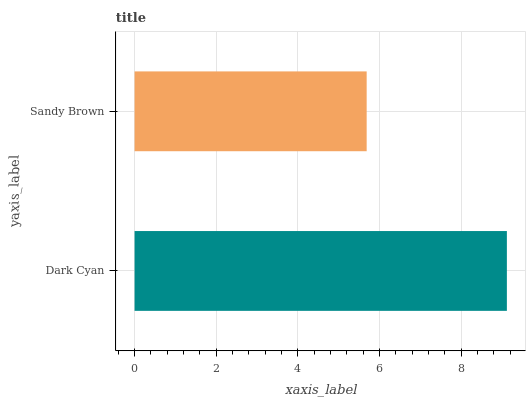Is Sandy Brown the minimum?
Answer yes or no. Yes. Is Dark Cyan the maximum?
Answer yes or no. Yes. Is Sandy Brown the maximum?
Answer yes or no. No. Is Dark Cyan greater than Sandy Brown?
Answer yes or no. Yes. Is Sandy Brown less than Dark Cyan?
Answer yes or no. Yes. Is Sandy Brown greater than Dark Cyan?
Answer yes or no. No. Is Dark Cyan less than Sandy Brown?
Answer yes or no. No. Is Dark Cyan the high median?
Answer yes or no. Yes. Is Sandy Brown the low median?
Answer yes or no. Yes. Is Sandy Brown the high median?
Answer yes or no. No. Is Dark Cyan the low median?
Answer yes or no. No. 